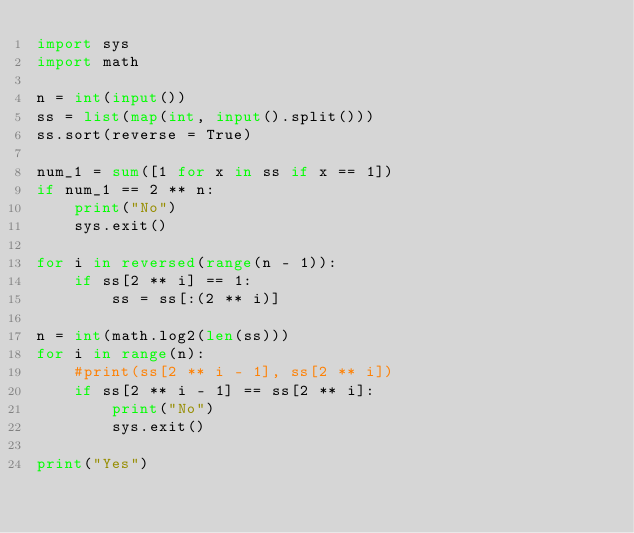<code> <loc_0><loc_0><loc_500><loc_500><_Python_>import sys
import math

n = int(input())
ss = list(map(int, input().split()))
ss.sort(reverse = True)

num_1 = sum([1 for x in ss if x == 1])
if num_1 == 2 ** n:
	print("No")
	sys.exit()

for i in reversed(range(n - 1)):
	if ss[2 ** i] == 1:
		ss = ss[:(2 ** i)]

n = int(math.log2(len(ss)))
for i in range(n):
	#print(ss[2 ** i - 1], ss[2 ** i])
	if ss[2 ** i - 1] == ss[2 ** i]:
		print("No")
		sys.exit()

print("Yes")
</code> 